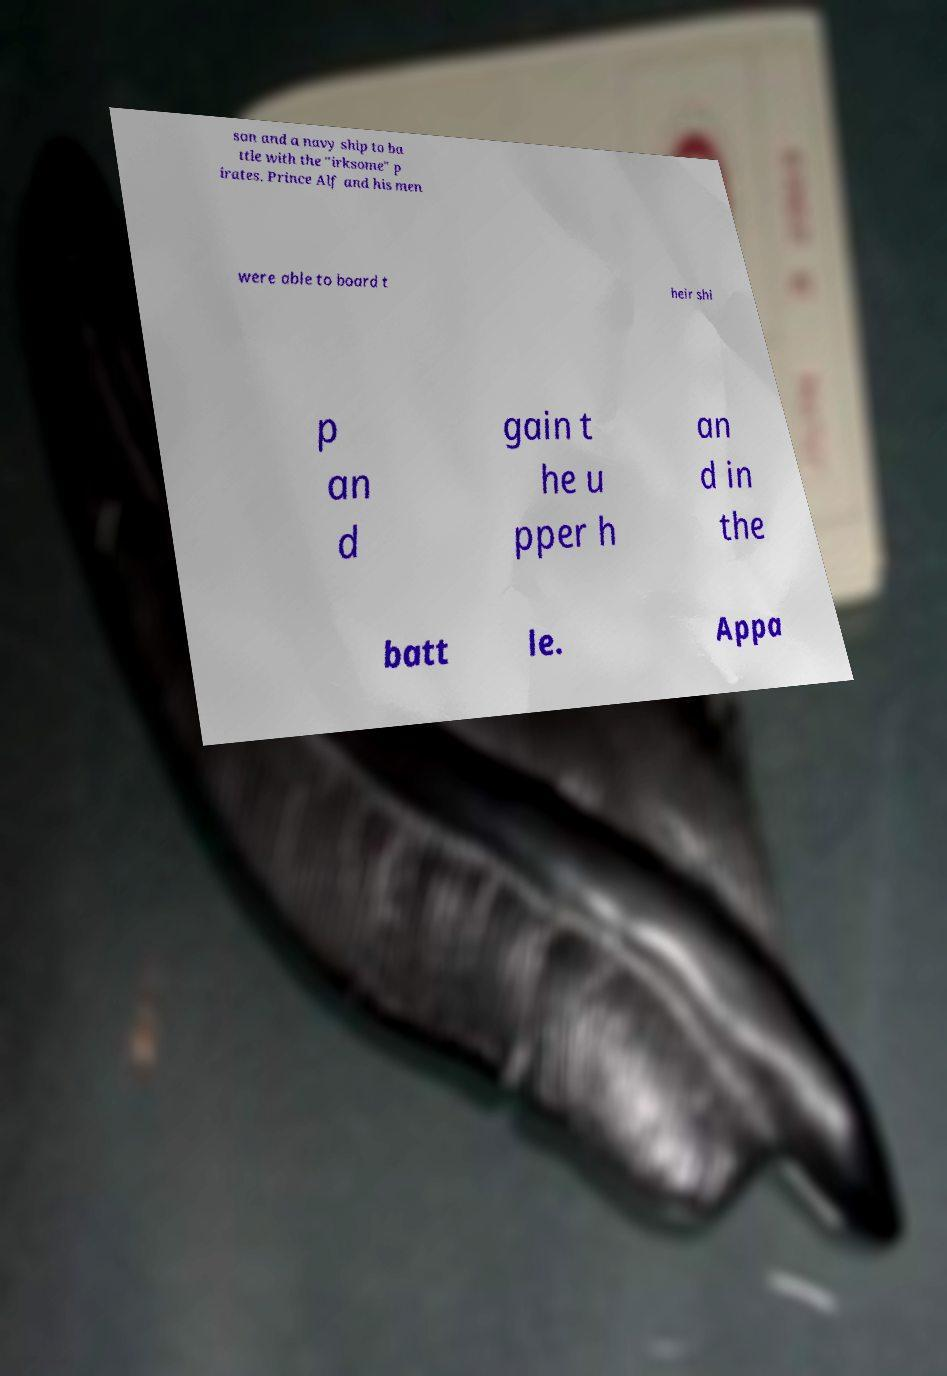Please identify and transcribe the text found in this image. son and a navy ship to ba ttle with the "irksome" p irates. Prince Alf and his men were able to board t heir shi p an d gain t he u pper h an d in the batt le. Appa 